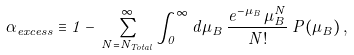<formula> <loc_0><loc_0><loc_500><loc_500>\alpha _ { e x c e s s } \equiv 1 - \, \sum _ { N = N _ { T o t a l } } ^ { \infty } \int _ { 0 } ^ { \infty } d \mu _ { B } \, \frac { e ^ { - \mu _ { B } } \, \mu _ { B } ^ { N } } { N ! } \, P ( \mu _ { B } ) \, ,</formula> 